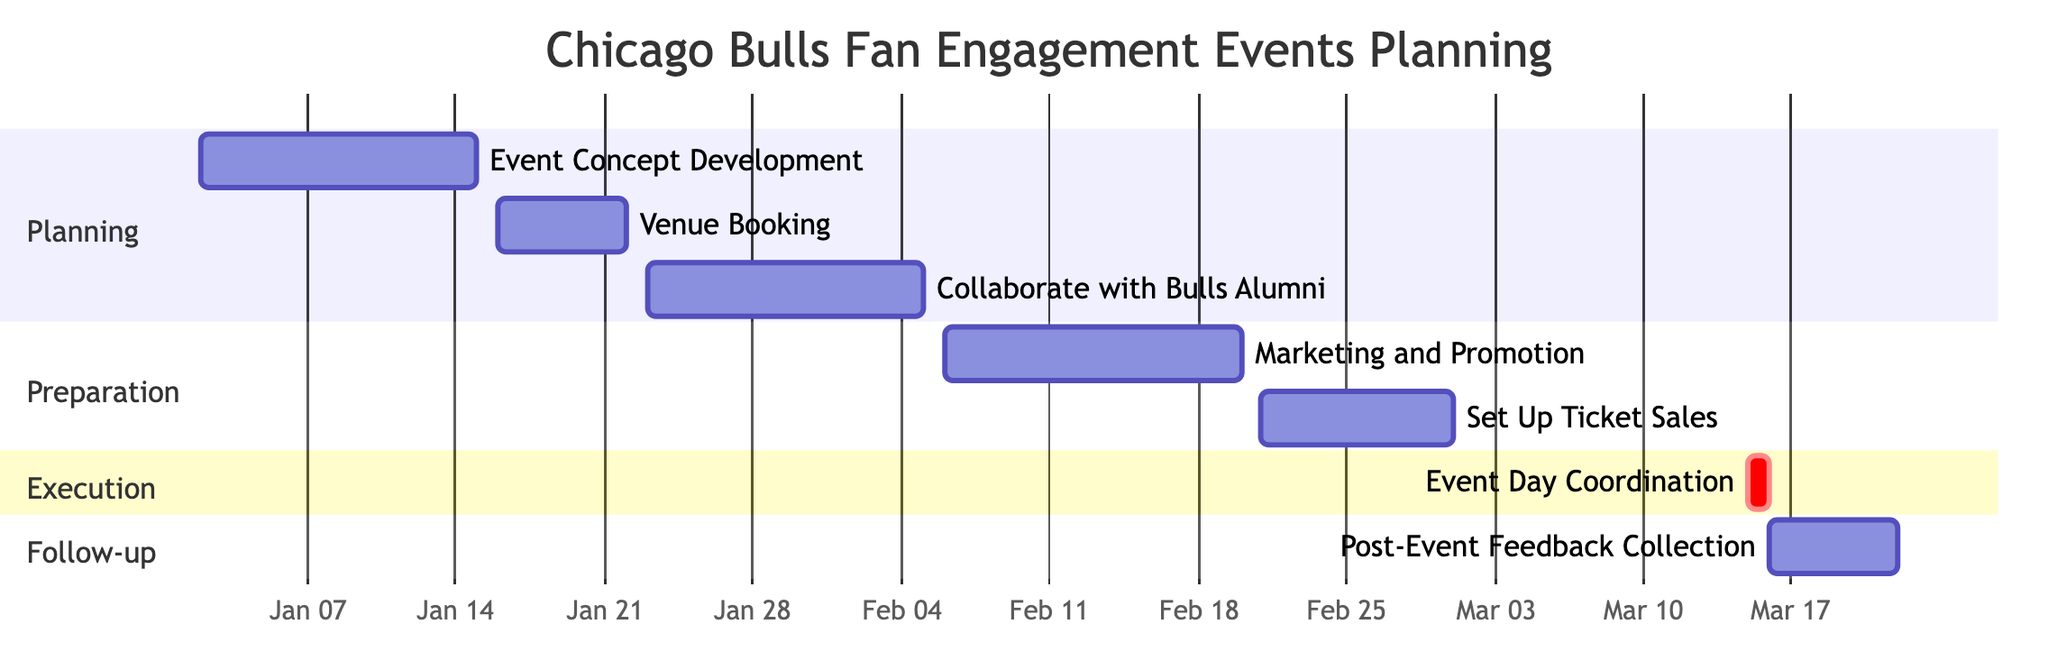What is the duration of the "Event Concept Development" task? The "Event Concept Development" task starts on January 2, 2024, and ends on January 15, 2024. To find the duration, we count the days from the start to the end date, which gives us 14 days.
Answer: 14 days What task follows "Venue Booking"? In the Gantt chart, "Venue Booking" ends on January 22, 2024, and "Collaborate with Bulls Alumni" starts immediately after on January 23, 2024. Hence, the task that follows "Venue Booking" is "Collaborate with Bulls Alumni."
Answer: Collaborate with Bulls Alumni How many tasks are in the "Preparation" section? The "Preparation" section includes two tasks: "Marketing and Promotion" and "Set Up Ticket Sales." Therefore, we add these tasks to find that there are 2 tasks in this section.
Answer: 2 What is the start date of "Set Up Ticket Sales"? The Gantt chart shows that "Set Up Ticket Sales" starts on February 21, 2024. This is a clear part of the timeline.
Answer: February 21, 2024 Which task is marked as critical? The Gantt chart indicates that "Event Day Coordination" is marked as critical, as denoted by the "crit" label. This means it is a high-priority task essential for the event's success.
Answer: Event Day Coordination What is the total number of tasks shown in the chart? By counting all the tasks listed across all sections (Planning, Preparation, Execution, and Follow-up), we find there are a total of 7 tasks outlined in the Gantt chart.
Answer: 7 How many days are allocated for "Post-Event Feedback Collection"? The task "Post-Event Feedback Collection" starts on March 16, 2024, and ends on March 22, 2024. By calculating from start to end inclusive, this task takes 7 days in total.
Answer: 7 days Which section contains "Marketing and Promotion"? According to the Gantt chart structure, "Marketing and Promotion" is found in the "Preparation" section, where this task takes place between February 6 and February 20, 2024.
Answer: Preparation What is the timeline for "Event Day Coordination"? The "Event Day Coordination" task is distinctly scheduled for one day on March 15, 2024. This makes it a single-day event entry in the Gantt chart.
Answer: March 15, 2024 